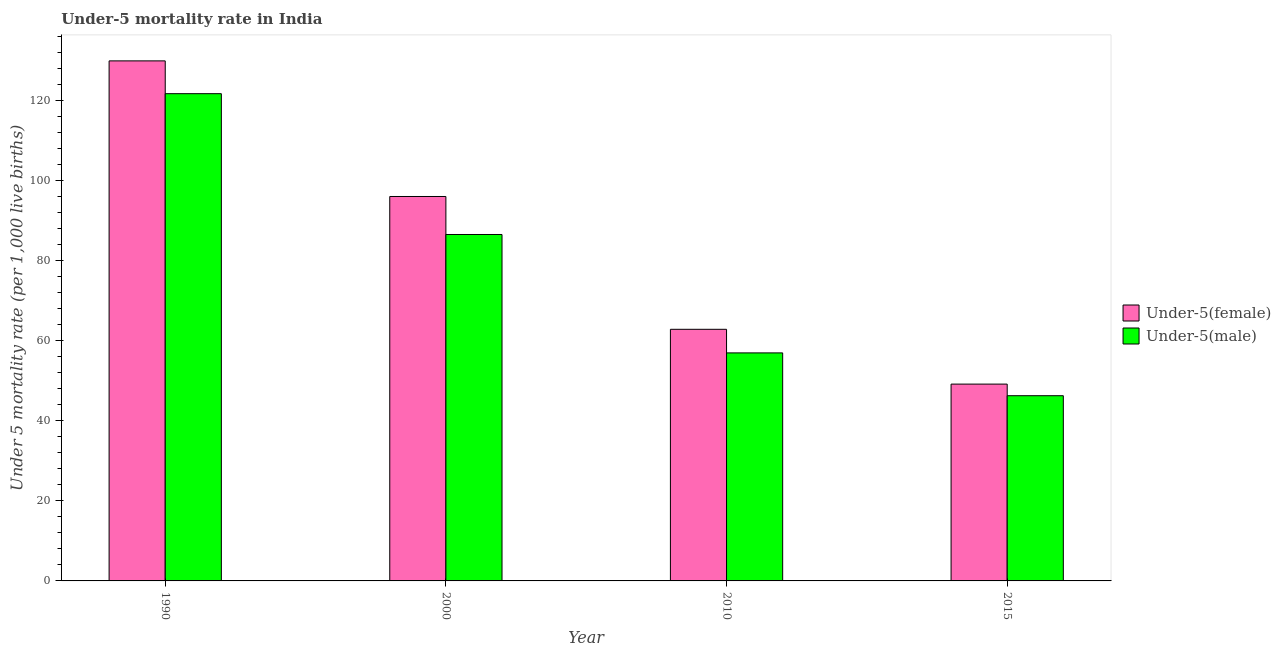Are the number of bars per tick equal to the number of legend labels?
Keep it short and to the point. Yes. Are the number of bars on each tick of the X-axis equal?
Provide a short and direct response. Yes. How many bars are there on the 1st tick from the left?
Provide a short and direct response. 2. What is the label of the 1st group of bars from the left?
Your answer should be very brief. 1990. What is the under-5 female mortality rate in 1990?
Offer a terse response. 130. Across all years, what is the maximum under-5 female mortality rate?
Provide a succinct answer. 130. Across all years, what is the minimum under-5 male mortality rate?
Keep it short and to the point. 46.3. In which year was the under-5 male mortality rate maximum?
Give a very brief answer. 1990. In which year was the under-5 female mortality rate minimum?
Keep it short and to the point. 2015. What is the total under-5 female mortality rate in the graph?
Offer a terse response. 338.2. What is the difference between the under-5 female mortality rate in 1990 and that in 2010?
Offer a terse response. 67.1. What is the difference between the under-5 female mortality rate in 1990 and the under-5 male mortality rate in 2000?
Provide a short and direct response. 33.9. What is the average under-5 female mortality rate per year?
Make the answer very short. 84.55. What is the ratio of the under-5 male mortality rate in 1990 to that in 2000?
Provide a succinct answer. 1.41. Is the under-5 female mortality rate in 1990 less than that in 2015?
Your answer should be very brief. No. What is the difference between the highest and the second highest under-5 male mortality rate?
Ensure brevity in your answer.  35.2. What is the difference between the highest and the lowest under-5 male mortality rate?
Keep it short and to the point. 75.5. Is the sum of the under-5 female mortality rate in 1990 and 2010 greater than the maximum under-5 male mortality rate across all years?
Provide a succinct answer. Yes. What does the 2nd bar from the left in 2000 represents?
Make the answer very short. Under-5(male). What does the 2nd bar from the right in 2010 represents?
Provide a succinct answer. Under-5(female). How many years are there in the graph?
Ensure brevity in your answer.  4. What is the difference between two consecutive major ticks on the Y-axis?
Give a very brief answer. 20. Does the graph contain any zero values?
Offer a terse response. No. Where does the legend appear in the graph?
Make the answer very short. Center right. How many legend labels are there?
Keep it short and to the point. 2. How are the legend labels stacked?
Offer a terse response. Vertical. What is the title of the graph?
Your response must be concise. Under-5 mortality rate in India. Does "Foreign Liabilities" appear as one of the legend labels in the graph?
Your answer should be compact. No. What is the label or title of the X-axis?
Your answer should be compact. Year. What is the label or title of the Y-axis?
Your response must be concise. Under 5 mortality rate (per 1,0 live births). What is the Under 5 mortality rate (per 1,000 live births) of Under-5(female) in 1990?
Your response must be concise. 130. What is the Under 5 mortality rate (per 1,000 live births) in Under-5(male) in 1990?
Make the answer very short. 121.8. What is the Under 5 mortality rate (per 1,000 live births) of Under-5(female) in 2000?
Provide a short and direct response. 96.1. What is the Under 5 mortality rate (per 1,000 live births) in Under-5(male) in 2000?
Make the answer very short. 86.6. What is the Under 5 mortality rate (per 1,000 live births) of Under-5(female) in 2010?
Give a very brief answer. 62.9. What is the Under 5 mortality rate (per 1,000 live births) of Under-5(female) in 2015?
Make the answer very short. 49.2. What is the Under 5 mortality rate (per 1,000 live births) of Under-5(male) in 2015?
Offer a terse response. 46.3. Across all years, what is the maximum Under 5 mortality rate (per 1,000 live births) of Under-5(female)?
Your response must be concise. 130. Across all years, what is the maximum Under 5 mortality rate (per 1,000 live births) in Under-5(male)?
Ensure brevity in your answer.  121.8. Across all years, what is the minimum Under 5 mortality rate (per 1,000 live births) in Under-5(female)?
Offer a very short reply. 49.2. Across all years, what is the minimum Under 5 mortality rate (per 1,000 live births) of Under-5(male)?
Make the answer very short. 46.3. What is the total Under 5 mortality rate (per 1,000 live births) of Under-5(female) in the graph?
Your answer should be very brief. 338.2. What is the total Under 5 mortality rate (per 1,000 live births) in Under-5(male) in the graph?
Provide a succinct answer. 311.7. What is the difference between the Under 5 mortality rate (per 1,000 live births) in Under-5(female) in 1990 and that in 2000?
Your response must be concise. 33.9. What is the difference between the Under 5 mortality rate (per 1,000 live births) in Under-5(male) in 1990 and that in 2000?
Offer a terse response. 35.2. What is the difference between the Under 5 mortality rate (per 1,000 live births) of Under-5(female) in 1990 and that in 2010?
Provide a short and direct response. 67.1. What is the difference between the Under 5 mortality rate (per 1,000 live births) of Under-5(male) in 1990 and that in 2010?
Give a very brief answer. 64.8. What is the difference between the Under 5 mortality rate (per 1,000 live births) in Under-5(female) in 1990 and that in 2015?
Provide a succinct answer. 80.8. What is the difference between the Under 5 mortality rate (per 1,000 live births) of Under-5(male) in 1990 and that in 2015?
Ensure brevity in your answer.  75.5. What is the difference between the Under 5 mortality rate (per 1,000 live births) in Under-5(female) in 2000 and that in 2010?
Offer a very short reply. 33.2. What is the difference between the Under 5 mortality rate (per 1,000 live births) in Under-5(male) in 2000 and that in 2010?
Ensure brevity in your answer.  29.6. What is the difference between the Under 5 mortality rate (per 1,000 live births) of Under-5(female) in 2000 and that in 2015?
Ensure brevity in your answer.  46.9. What is the difference between the Under 5 mortality rate (per 1,000 live births) of Under-5(male) in 2000 and that in 2015?
Provide a succinct answer. 40.3. What is the difference between the Under 5 mortality rate (per 1,000 live births) in Under-5(female) in 2010 and that in 2015?
Give a very brief answer. 13.7. What is the difference between the Under 5 mortality rate (per 1,000 live births) of Under-5(female) in 1990 and the Under 5 mortality rate (per 1,000 live births) of Under-5(male) in 2000?
Keep it short and to the point. 43.4. What is the difference between the Under 5 mortality rate (per 1,000 live births) of Under-5(female) in 1990 and the Under 5 mortality rate (per 1,000 live births) of Under-5(male) in 2010?
Provide a succinct answer. 73. What is the difference between the Under 5 mortality rate (per 1,000 live births) in Under-5(female) in 1990 and the Under 5 mortality rate (per 1,000 live births) in Under-5(male) in 2015?
Make the answer very short. 83.7. What is the difference between the Under 5 mortality rate (per 1,000 live births) in Under-5(female) in 2000 and the Under 5 mortality rate (per 1,000 live births) in Under-5(male) in 2010?
Ensure brevity in your answer.  39.1. What is the difference between the Under 5 mortality rate (per 1,000 live births) in Under-5(female) in 2000 and the Under 5 mortality rate (per 1,000 live births) in Under-5(male) in 2015?
Ensure brevity in your answer.  49.8. What is the average Under 5 mortality rate (per 1,000 live births) in Under-5(female) per year?
Make the answer very short. 84.55. What is the average Under 5 mortality rate (per 1,000 live births) of Under-5(male) per year?
Make the answer very short. 77.92. In the year 2000, what is the difference between the Under 5 mortality rate (per 1,000 live births) in Under-5(female) and Under 5 mortality rate (per 1,000 live births) in Under-5(male)?
Keep it short and to the point. 9.5. In the year 2010, what is the difference between the Under 5 mortality rate (per 1,000 live births) in Under-5(female) and Under 5 mortality rate (per 1,000 live births) in Under-5(male)?
Your response must be concise. 5.9. What is the ratio of the Under 5 mortality rate (per 1,000 live births) in Under-5(female) in 1990 to that in 2000?
Ensure brevity in your answer.  1.35. What is the ratio of the Under 5 mortality rate (per 1,000 live births) in Under-5(male) in 1990 to that in 2000?
Offer a terse response. 1.41. What is the ratio of the Under 5 mortality rate (per 1,000 live births) in Under-5(female) in 1990 to that in 2010?
Keep it short and to the point. 2.07. What is the ratio of the Under 5 mortality rate (per 1,000 live births) of Under-5(male) in 1990 to that in 2010?
Provide a succinct answer. 2.14. What is the ratio of the Under 5 mortality rate (per 1,000 live births) of Under-5(female) in 1990 to that in 2015?
Your answer should be very brief. 2.64. What is the ratio of the Under 5 mortality rate (per 1,000 live births) of Under-5(male) in 1990 to that in 2015?
Offer a very short reply. 2.63. What is the ratio of the Under 5 mortality rate (per 1,000 live births) in Under-5(female) in 2000 to that in 2010?
Give a very brief answer. 1.53. What is the ratio of the Under 5 mortality rate (per 1,000 live births) in Under-5(male) in 2000 to that in 2010?
Ensure brevity in your answer.  1.52. What is the ratio of the Under 5 mortality rate (per 1,000 live births) of Under-5(female) in 2000 to that in 2015?
Ensure brevity in your answer.  1.95. What is the ratio of the Under 5 mortality rate (per 1,000 live births) of Under-5(male) in 2000 to that in 2015?
Your response must be concise. 1.87. What is the ratio of the Under 5 mortality rate (per 1,000 live births) of Under-5(female) in 2010 to that in 2015?
Give a very brief answer. 1.28. What is the ratio of the Under 5 mortality rate (per 1,000 live births) of Under-5(male) in 2010 to that in 2015?
Give a very brief answer. 1.23. What is the difference between the highest and the second highest Under 5 mortality rate (per 1,000 live births) in Under-5(female)?
Provide a succinct answer. 33.9. What is the difference between the highest and the second highest Under 5 mortality rate (per 1,000 live births) in Under-5(male)?
Your answer should be compact. 35.2. What is the difference between the highest and the lowest Under 5 mortality rate (per 1,000 live births) of Under-5(female)?
Make the answer very short. 80.8. What is the difference between the highest and the lowest Under 5 mortality rate (per 1,000 live births) of Under-5(male)?
Your answer should be compact. 75.5. 